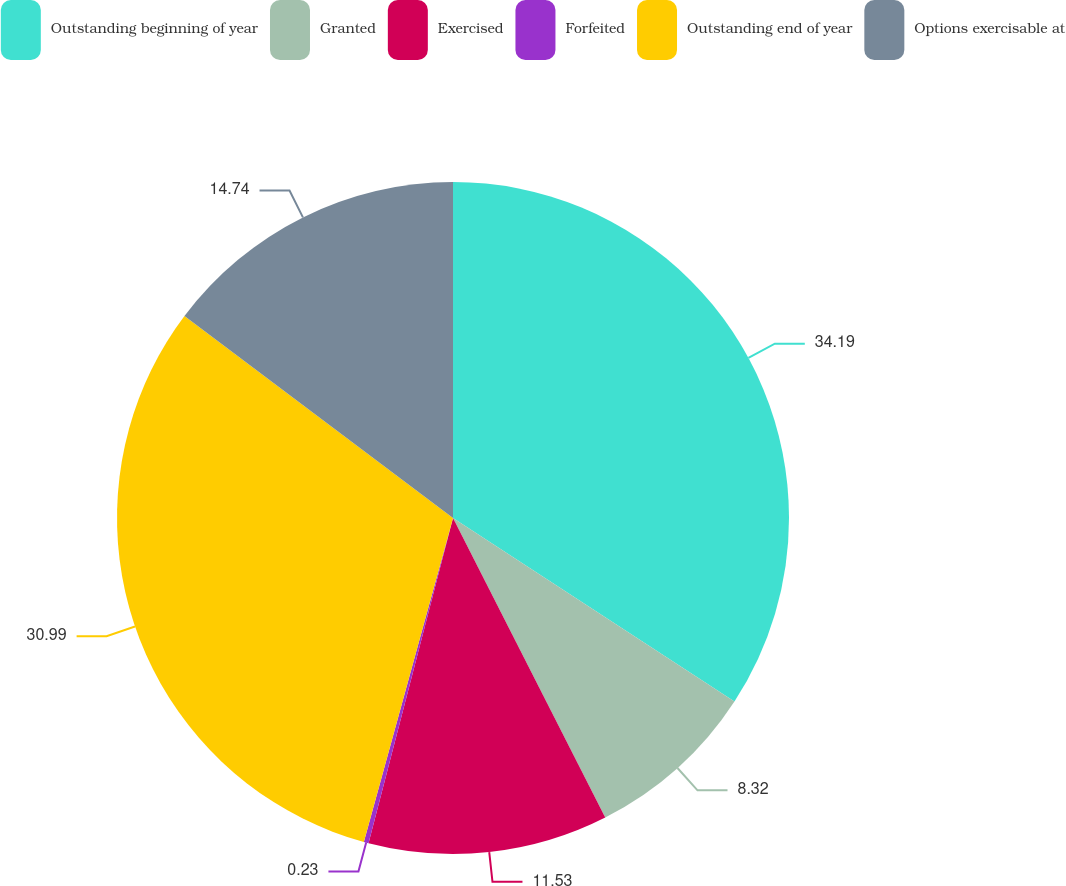Convert chart. <chart><loc_0><loc_0><loc_500><loc_500><pie_chart><fcel>Outstanding beginning of year<fcel>Granted<fcel>Exercised<fcel>Forfeited<fcel>Outstanding end of year<fcel>Options exercisable at<nl><fcel>34.2%<fcel>8.32%<fcel>11.53%<fcel>0.23%<fcel>30.99%<fcel>14.74%<nl></chart> 